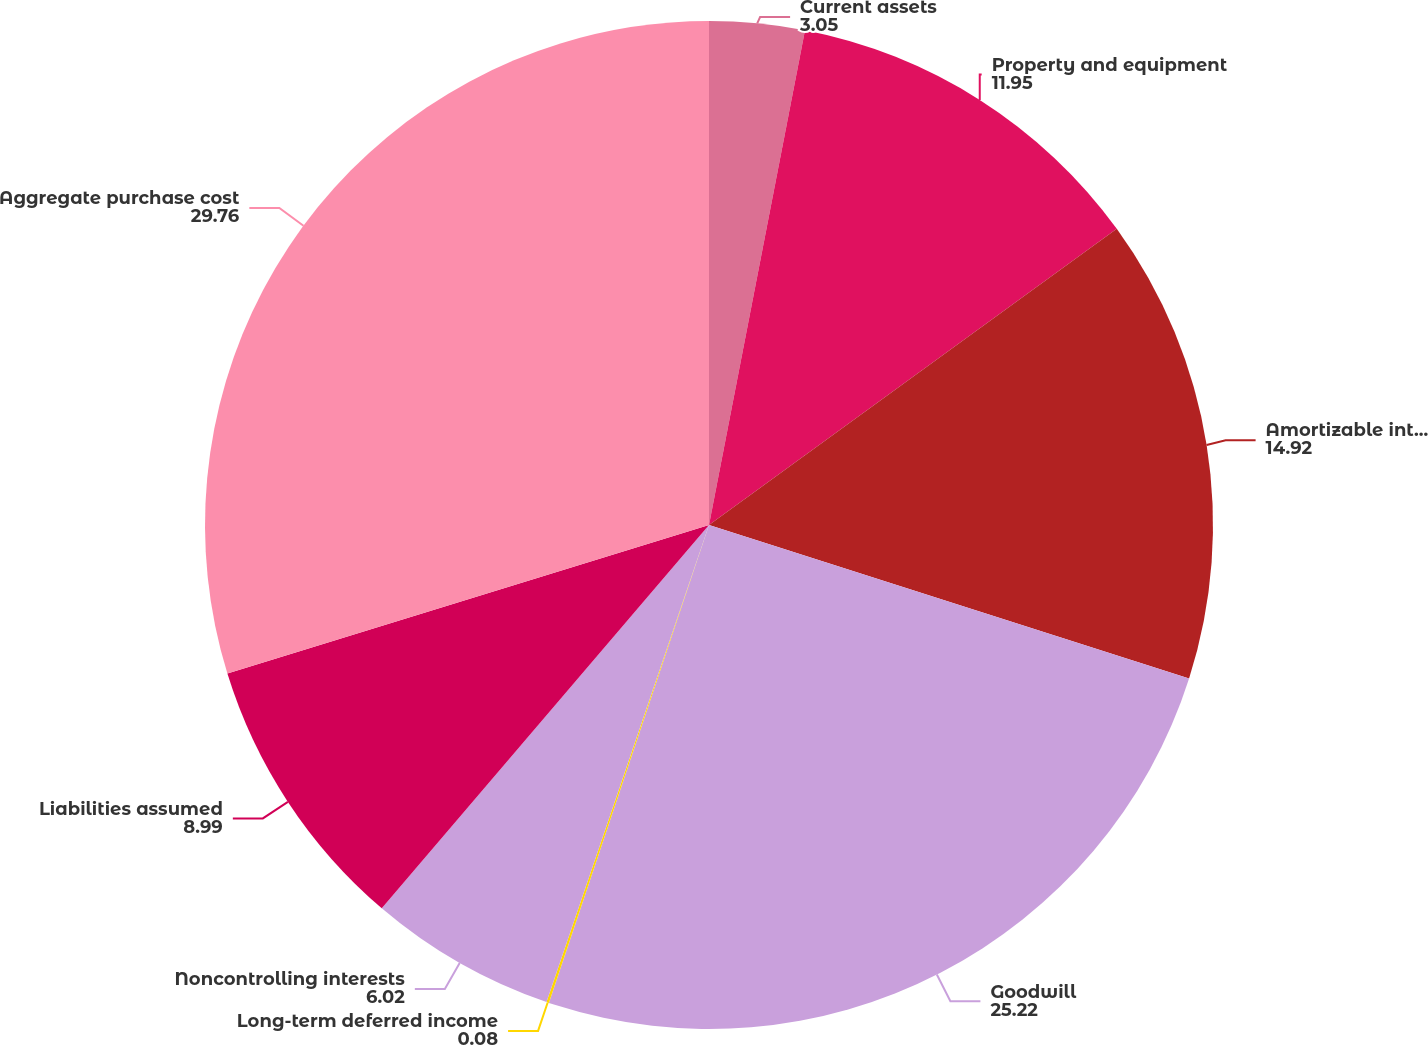<chart> <loc_0><loc_0><loc_500><loc_500><pie_chart><fcel>Current assets<fcel>Property and equipment<fcel>Amortizable intangible and<fcel>Goodwill<fcel>Long-term deferred income<fcel>Noncontrolling interests<fcel>Liabilities assumed<fcel>Aggregate purchase cost<nl><fcel>3.05%<fcel>11.95%<fcel>14.92%<fcel>25.22%<fcel>0.08%<fcel>6.02%<fcel>8.99%<fcel>29.76%<nl></chart> 